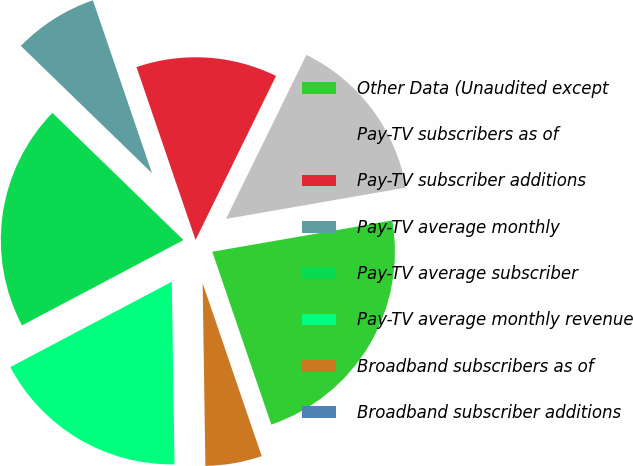Convert chart. <chart><loc_0><loc_0><loc_500><loc_500><pie_chart><fcel>Other Data (Unaudited except<fcel>Pay-TV subscribers as of<fcel>Pay-TV subscriber additions<fcel>Pay-TV average monthly<fcel>Pay-TV average subscriber<fcel>Pay-TV average monthly revenue<fcel>Broadband subscribers as of<fcel>Broadband subscriber additions<nl><fcel>22.5%<fcel>15.0%<fcel>12.5%<fcel>7.5%<fcel>20.0%<fcel>17.5%<fcel>5.0%<fcel>0.0%<nl></chart> 